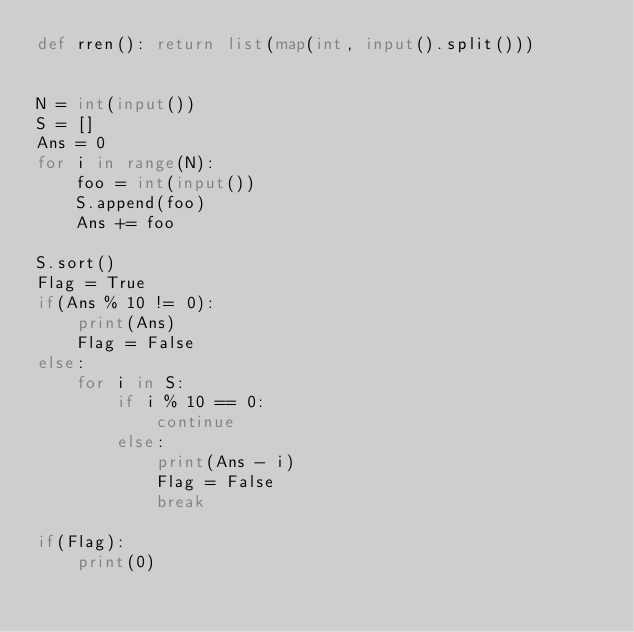Convert code to text. <code><loc_0><loc_0><loc_500><loc_500><_Python_>def rren(): return list(map(int, input().split()))


N = int(input())
S = []
Ans = 0
for i in range(N):
    foo = int(input())
    S.append(foo)
    Ans += foo

S.sort()
Flag = True
if(Ans % 10 != 0):
    print(Ans)
    Flag = False
else:
    for i in S:
        if i % 10 == 0:
            continue
        else:
            print(Ans - i)
            Flag = False
            break

if(Flag):
    print(0)
</code> 